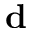<formula> <loc_0><loc_0><loc_500><loc_500>d</formula> 